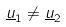<formula> <loc_0><loc_0><loc_500><loc_500>\underline { u } _ { 1 } \ne \underline { u } _ { 2 }</formula> 